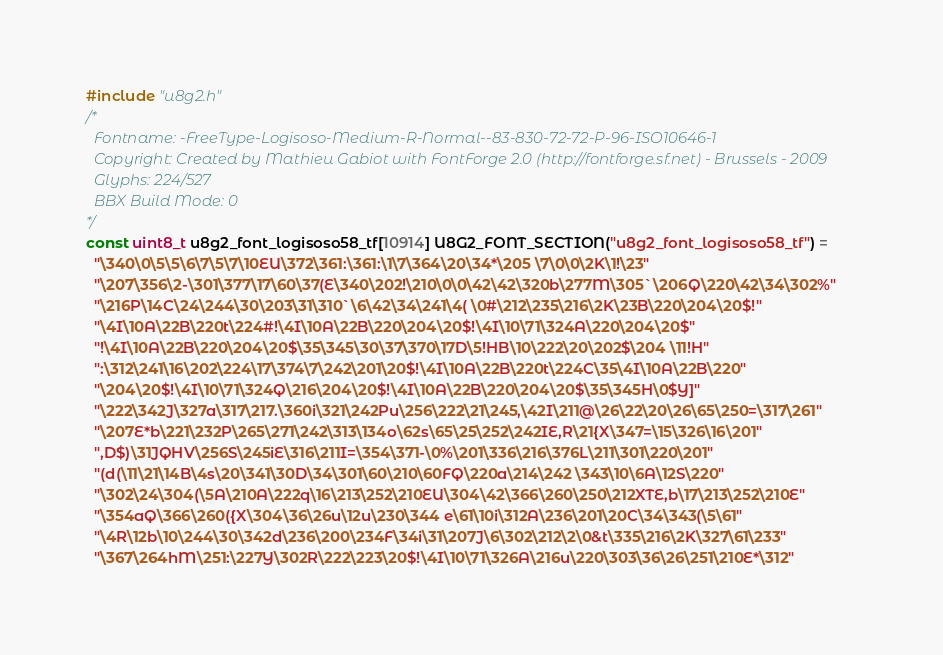<code> <loc_0><loc_0><loc_500><loc_500><_C_>#include "u8g2.h"
/*
  Fontname: -FreeType-Logisoso-Medium-R-Normal--83-830-72-72-P-96-ISO10646-1
  Copyright: Created by Mathieu Gabiot with FontForge 2.0 (http://fontforge.sf.net) - Brussels - 2009
  Glyphs: 224/527
  BBX Build Mode: 0
*/
const uint8_t u8g2_font_logisoso58_tf[10914] U8G2_FONT_SECTION("u8g2_font_logisoso58_tf") = 
  "\340\0\5\5\6\7\5\7\10EU\372\361:\361:\1\7\364\20\34*\205 \7\0\0\2K\1!\23"
  "\207\356\2-\301\377\17\60\37(E\340\202!\210\0\0\42\42\320b\277M\305`\206Q\220\42\34\302%"
  "\216P\14C\24\244\30\203\31\310`\6\42\34\241\4( \0#\212\235\216\2K\23B\220\204\20$!"
  "\4I\10A\22B\220t\224#!\4I\10A\22B\220\204\20$!\4I\10\71\324A\220\204\20$"
  "!\4I\10A\22B\220\204\20$\35\345\30\37\370\17D\5!HB\10\222\20\202$\204 \11!H"
  ":\312\241\16\202\224\17\374\7\242\201\20$!\4I\10A\22B\220t\224C\35\4I\10A\22B\220"
  "\204\20$!\4I\10\71\324Q\216\204\20$!\4I\10A\22B\220\204\20$\35\345H\0$Y]"
  "\222\342J\327a\317\217.\360i\321\242Pu\256\222\21\245,\42I\211@\26\22\20\26\65\250=\317\261"
  "\207E*b\221\232P\265\271\242\313\134o\62s\65\25\252\242IE,R\21{X\347=\15\326\16\201"
  ",D$)\31JQHV\256S\245iE\316\211I=\354\371-\0%\201\336\216\376L\211\301\220\201"
  "(d(\11\21\14B\4s\20\341\30D\34\301\60\210\60FQ\220a\214\242 \343\10\6A\12S\220"
  "\302\24\304(\5A\210A\222q\16\213\252\210EU\304\42\366\260\250\212XTE,b\17\213\252\210E"
  "\354aQ\366\260({X\304\36\26u\12u\230\344 e\61\10i\312A\236\201\20C\34\343(\5\61"
  "\4R\12b\10\244\30\342d\236\200\234F\34i\31\207J\6\302\212\2\0&t\335\216\2K\327\61\233"
  "\367\264hM\251:\227Y\302R\222\223\20$!\4I\10\71\326A\216u\220\303\36\26\251\210E*\312"</code> 